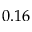<formula> <loc_0><loc_0><loc_500><loc_500>0 . 1 6</formula> 